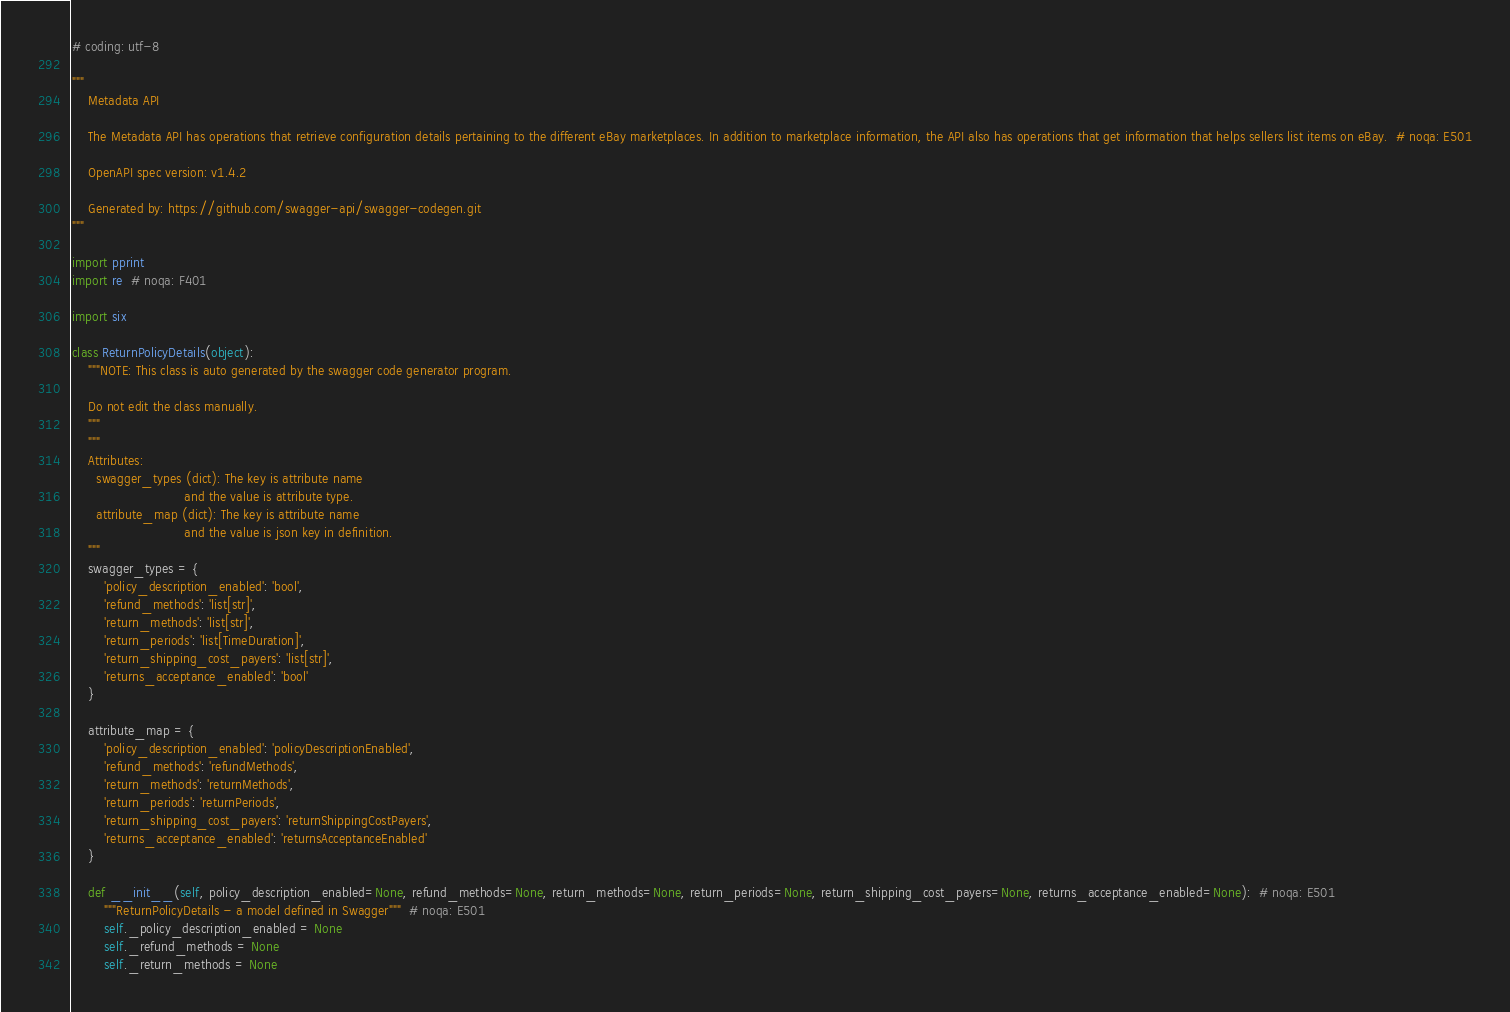<code> <loc_0><loc_0><loc_500><loc_500><_Python_># coding: utf-8

"""
    Metadata API

    The Metadata API has operations that retrieve configuration details pertaining to the different eBay marketplaces. In addition to marketplace information, the API also has operations that get information that helps sellers list items on eBay.  # noqa: E501

    OpenAPI spec version: v1.4.2
    
    Generated by: https://github.com/swagger-api/swagger-codegen.git
"""

import pprint
import re  # noqa: F401

import six

class ReturnPolicyDetails(object):
    """NOTE: This class is auto generated by the swagger code generator program.

    Do not edit the class manually.
    """
    """
    Attributes:
      swagger_types (dict): The key is attribute name
                            and the value is attribute type.
      attribute_map (dict): The key is attribute name
                            and the value is json key in definition.
    """
    swagger_types = {
        'policy_description_enabled': 'bool',
        'refund_methods': 'list[str]',
        'return_methods': 'list[str]',
        'return_periods': 'list[TimeDuration]',
        'return_shipping_cost_payers': 'list[str]',
        'returns_acceptance_enabled': 'bool'
    }

    attribute_map = {
        'policy_description_enabled': 'policyDescriptionEnabled',
        'refund_methods': 'refundMethods',
        'return_methods': 'returnMethods',
        'return_periods': 'returnPeriods',
        'return_shipping_cost_payers': 'returnShippingCostPayers',
        'returns_acceptance_enabled': 'returnsAcceptanceEnabled'
    }

    def __init__(self, policy_description_enabled=None, refund_methods=None, return_methods=None, return_periods=None, return_shipping_cost_payers=None, returns_acceptance_enabled=None):  # noqa: E501
        """ReturnPolicyDetails - a model defined in Swagger"""  # noqa: E501
        self._policy_description_enabled = None
        self._refund_methods = None
        self._return_methods = None</code> 